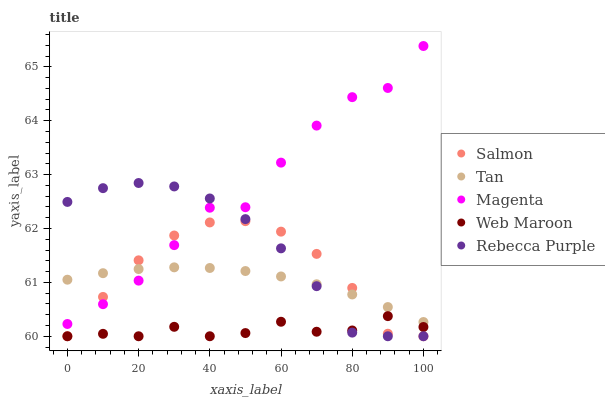Does Web Maroon have the minimum area under the curve?
Answer yes or no. Yes. Does Magenta have the maximum area under the curve?
Answer yes or no. Yes. Does Tan have the minimum area under the curve?
Answer yes or no. No. Does Tan have the maximum area under the curve?
Answer yes or no. No. Is Tan the smoothest?
Answer yes or no. Yes. Is Magenta the roughest?
Answer yes or no. Yes. Is Salmon the smoothest?
Answer yes or no. No. Is Salmon the roughest?
Answer yes or no. No. Does Web Maroon have the lowest value?
Answer yes or no. Yes. Does Tan have the lowest value?
Answer yes or no. No. Does Magenta have the highest value?
Answer yes or no. Yes. Does Tan have the highest value?
Answer yes or no. No. Is Web Maroon less than Tan?
Answer yes or no. Yes. Is Tan greater than Web Maroon?
Answer yes or no. Yes. Does Tan intersect Rebecca Purple?
Answer yes or no. Yes. Is Tan less than Rebecca Purple?
Answer yes or no. No. Is Tan greater than Rebecca Purple?
Answer yes or no. No. Does Web Maroon intersect Tan?
Answer yes or no. No. 